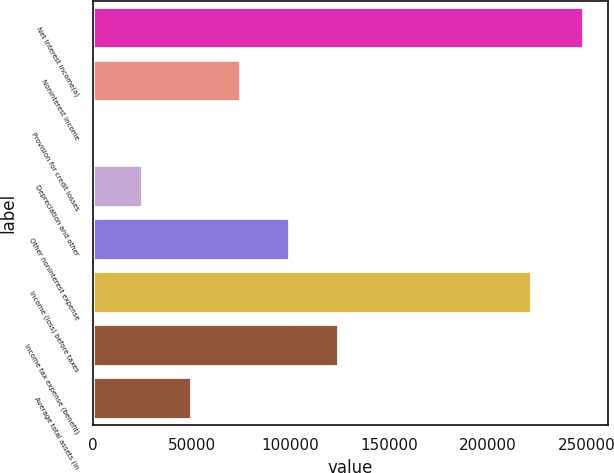Convert chart to OTSL. <chart><loc_0><loc_0><loc_500><loc_500><bar_chart><fcel>Net interest income(a)<fcel>Noninterest income<fcel>Provision for credit losses<fcel>Depreciation and other<fcel>Other noninterest expense<fcel>Income (loss) before taxes<fcel>Income tax expense (benefit)<fcel>Average total assets (in<nl><fcel>248304<fcel>74901.4<fcel>586<fcel>25357.8<fcel>99673.2<fcel>221934<fcel>124445<fcel>50129.6<nl></chart> 